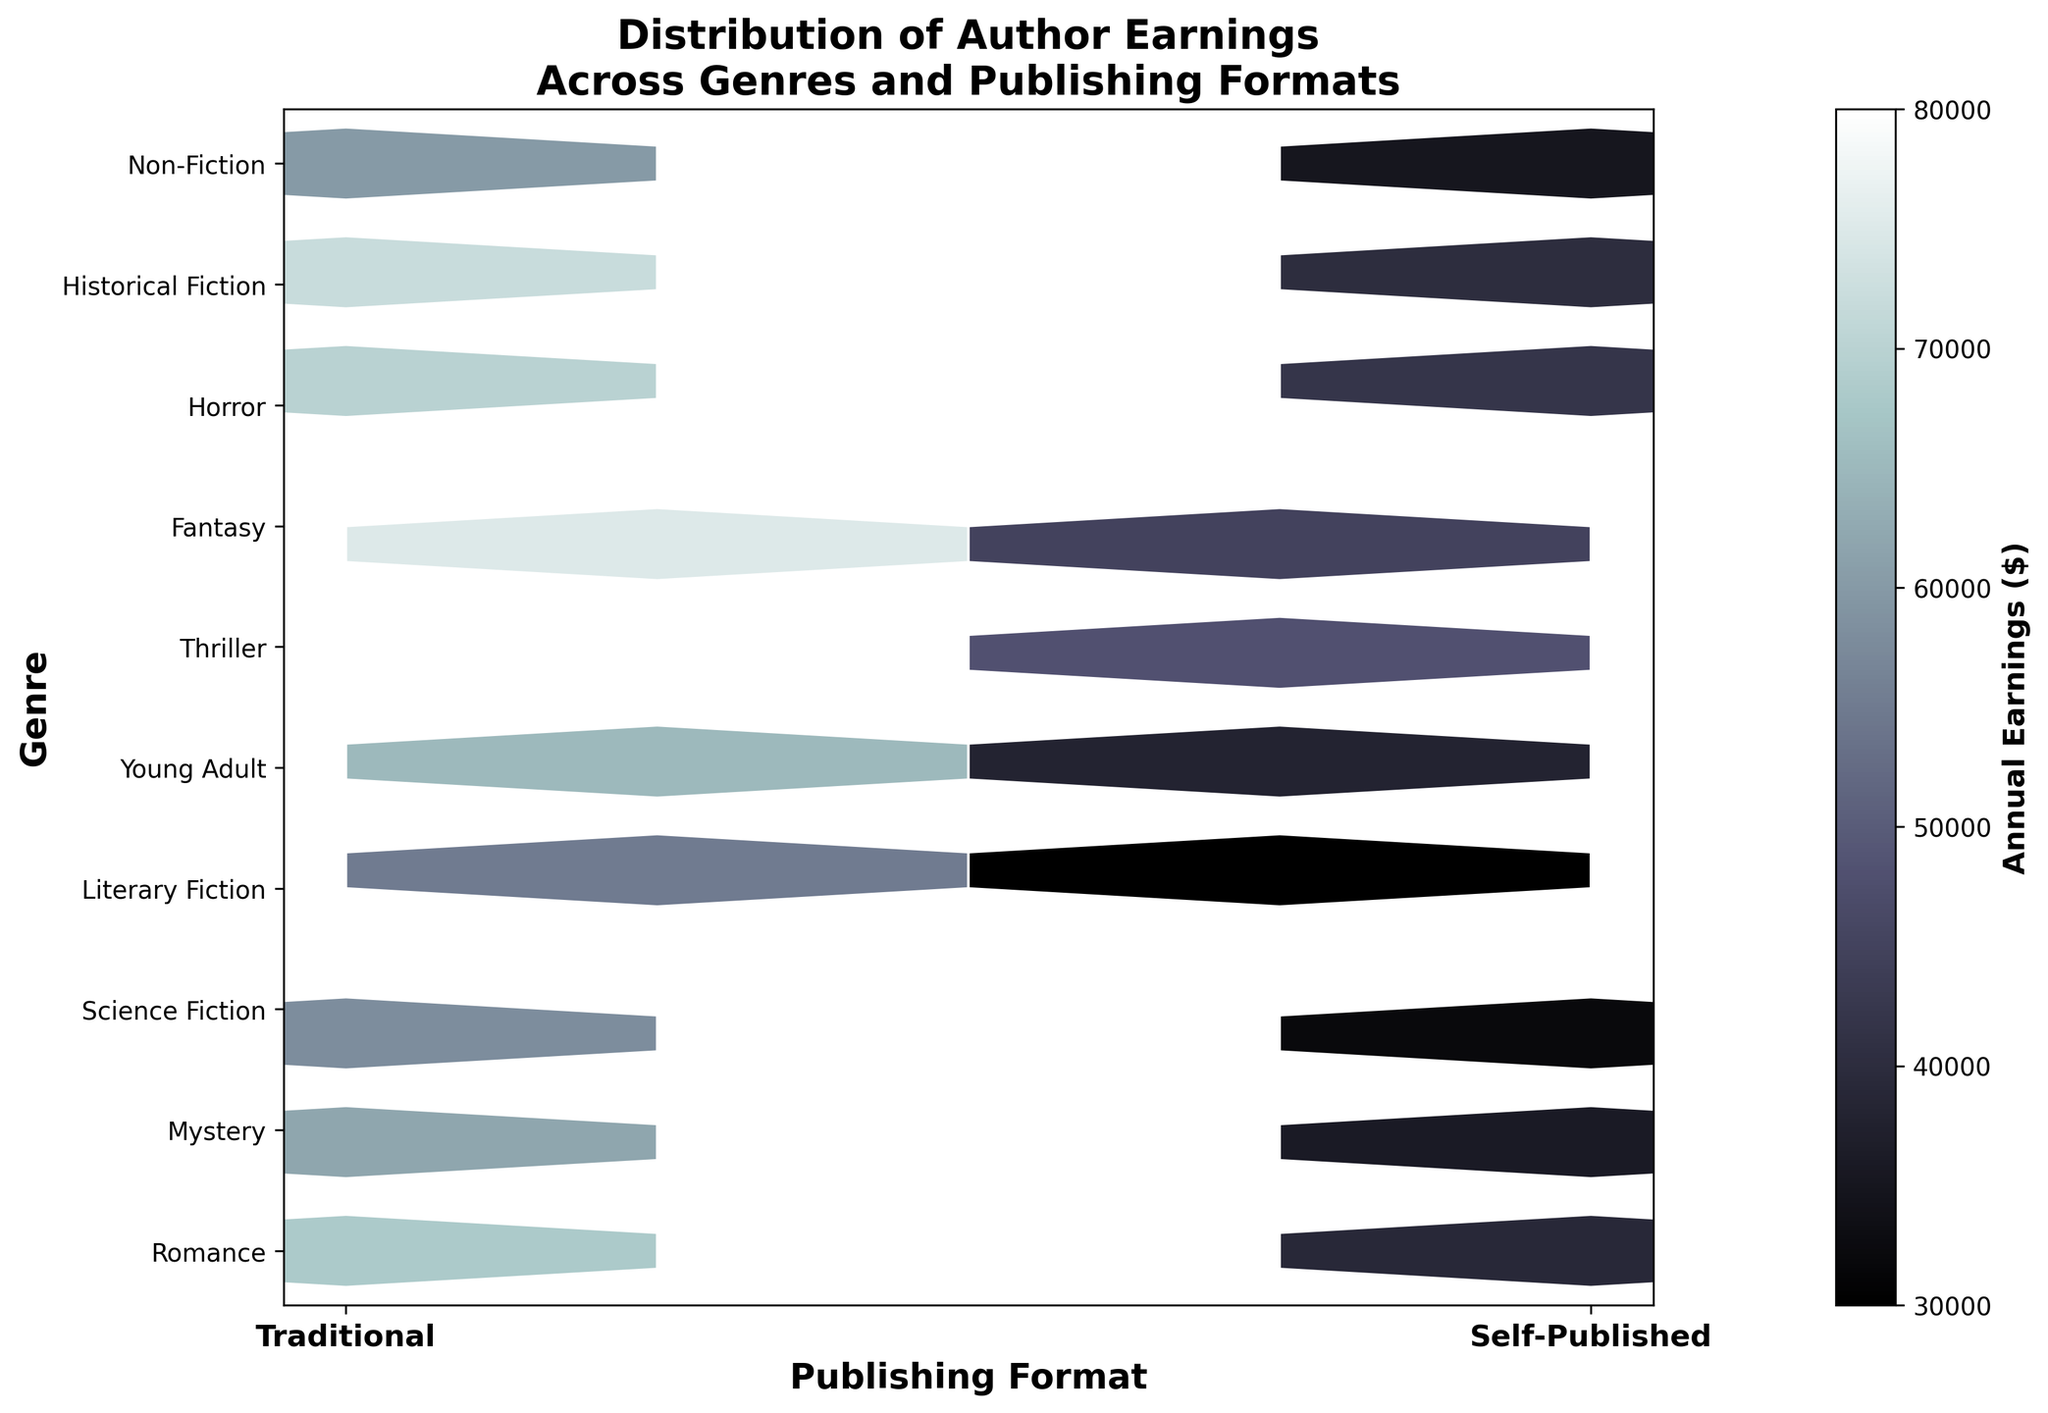what is the title of the plot? The title is usually found at the top of the plot and provides an overview of the information being visualized. It gives viewers a context of what they're looking at. In this case, it's clearly written at the top.
Answer: Distribution of Author Earnings Across Genres and Publishing Formats how many categories of genres are visualized in the plot? The different categories of genres are represented along the y-axis. By counting the unique labels on this axis, we can find the total number of genres shown.
Answer: 10 what do the colors of the hexagons represent? In a hexbin plot, colors typically represent the density or an aggregated value of the data points within the hexagon. Here, the color intensity is explained by the color bar, which shows that it corresponds to the annual earnings in dollars.
Answer: Annual earnings ($) which publishing format generally has higher earnings based on the color intensity of the hexagons? Compare the color intensity of hexagons corresponding to Traditional (0) and Self-Published (1) along the x-axis. The hexagons on the Traditional (0) side are generally darker, indicating higher earnings.
Answer: Traditional what is the maximum annual earnings indicated by the color bar? Look at the upper limit of the color bar, which shows the range of values it represents. The top-most value on the color bar corresponds to the maximum annual earnings.
Answer: 80000 which genre has the highest earnings for self-published authors? Find the genre along the y-axis and look at the hexagons corresponding to Self-Published (1) on the x-axis. The genre with the darkest hexagon will have the highest earnings for self-published authors.
Answer: Non-Fiction compare the earnings of Traditional and Self-Published authors in the Thriller genre. Locate Thriller on the y-axis and compare the color intensity of hexagons at Traditional (0) and Self-Published (1) on the x-axis. Darker colors indicate higher earnings.
Answer: Traditional authors earn more which genre shows a minimal difference in earnings between Traditional and Self-Published formats? For this, you'll need to compare the color intensities of the hexagons for each genre at Traditional (0) and Self-Published (1). The genre with the most similar color intensities has the minimal difference.
Answer: Fantasy what is the approximate range of annual earnings for the Mystery genre in both Publishing Formats? Identify the Mystery genre on the y-axis and refer to the color intensity of hexagons on both Traditional (0) and Self-Published (1). Compare these colors to the color bar to find the range.
Answer: $38000 to $65000 